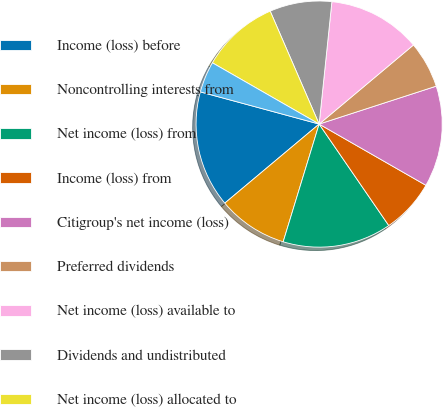Convert chart. <chart><loc_0><loc_0><loc_500><loc_500><pie_chart><fcel>Income (loss) before<fcel>Noncontrolling interests from<fcel>Net income (loss) from<fcel>Income (loss) from<fcel>Citigroup's net income (loss)<fcel>Preferred dividends<fcel>Net income (loss) available to<fcel>Dividends and undistributed<fcel>Net income (loss) allocated to<fcel>Effect of dilutive securities<nl><fcel>15.31%<fcel>9.18%<fcel>14.29%<fcel>7.14%<fcel>13.27%<fcel>6.12%<fcel>12.24%<fcel>8.16%<fcel>10.2%<fcel>4.08%<nl></chart> 